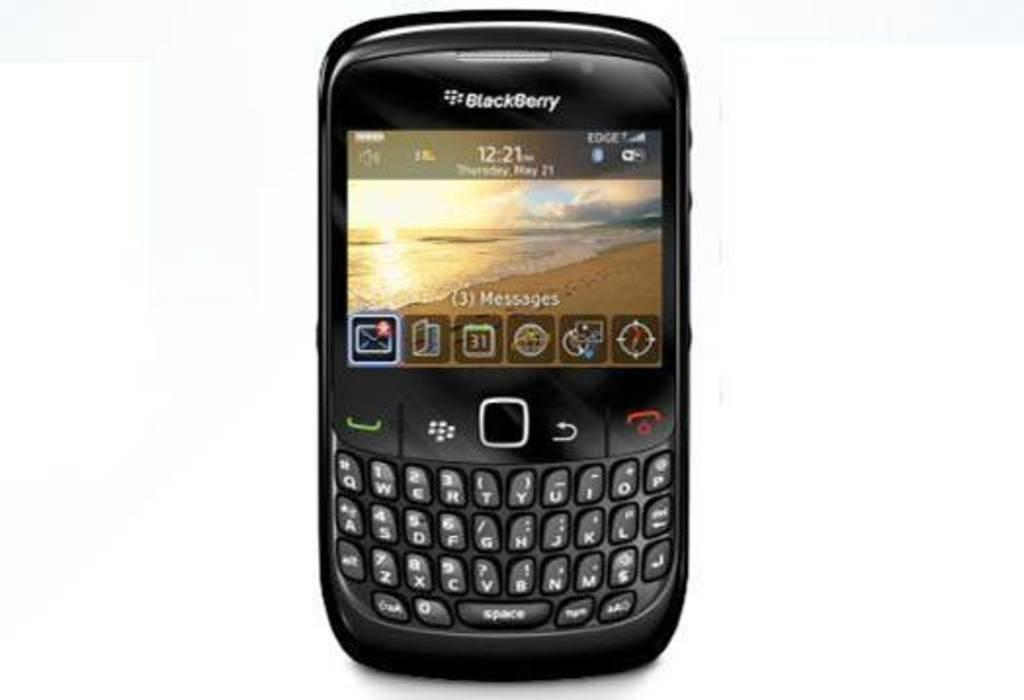<image>
Render a clear and concise summary of the photo. A Blackberry phone has a sunset on the screen, above the keys with letters and numbers on them. 